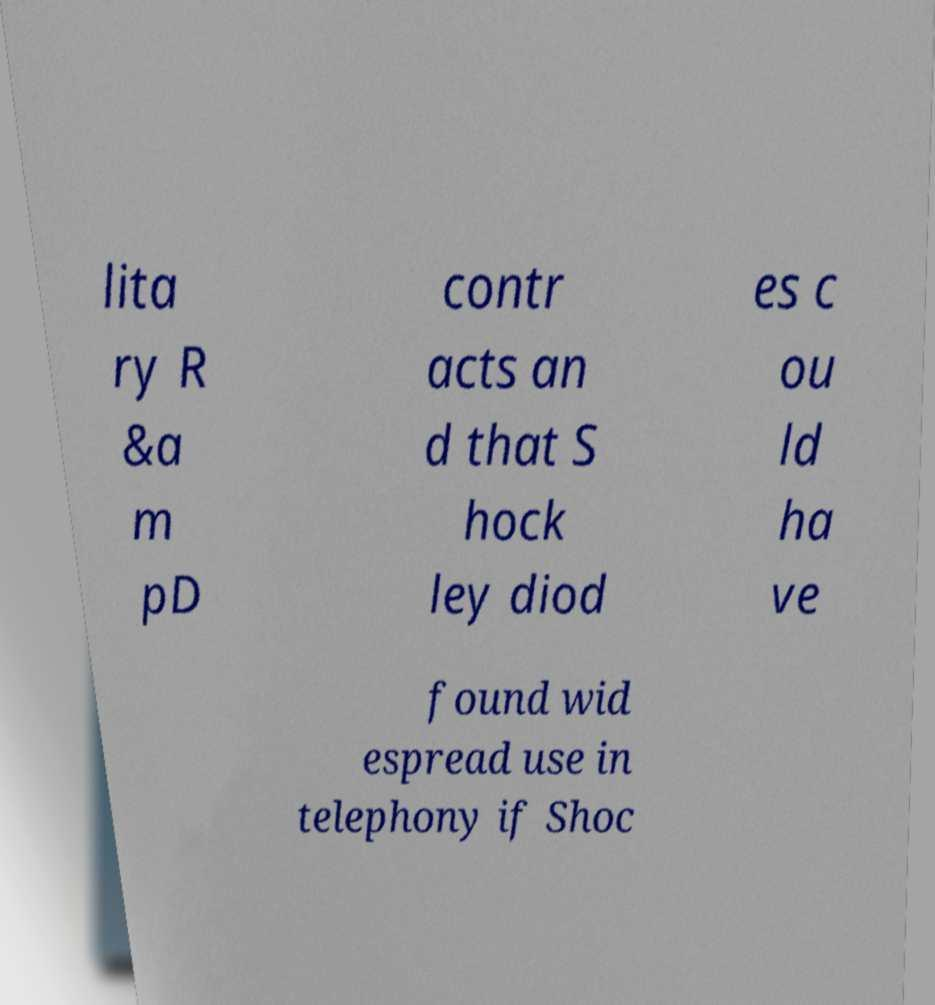What messages or text are displayed in this image? I need them in a readable, typed format. lita ry R &a m pD contr acts an d that S hock ley diod es c ou ld ha ve found wid espread use in telephony if Shoc 